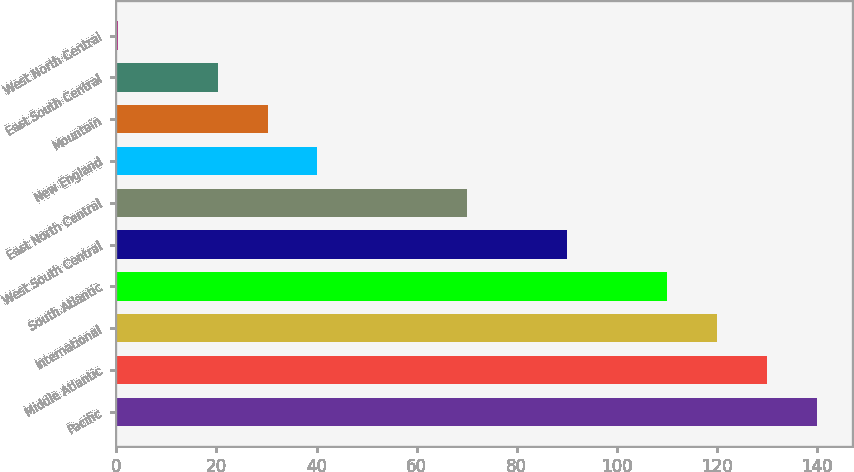<chart> <loc_0><loc_0><loc_500><loc_500><bar_chart><fcel>Pacific<fcel>Middle Atlantic<fcel>International<fcel>South Atlantic<fcel>West South Central<fcel>East North Central<fcel>New England<fcel>Mountain<fcel>East South Central<fcel>West North Central<nl><fcel>139.88<fcel>129.91<fcel>119.94<fcel>109.97<fcel>90.03<fcel>70.09<fcel>40.18<fcel>30.21<fcel>20.24<fcel>0.3<nl></chart> 